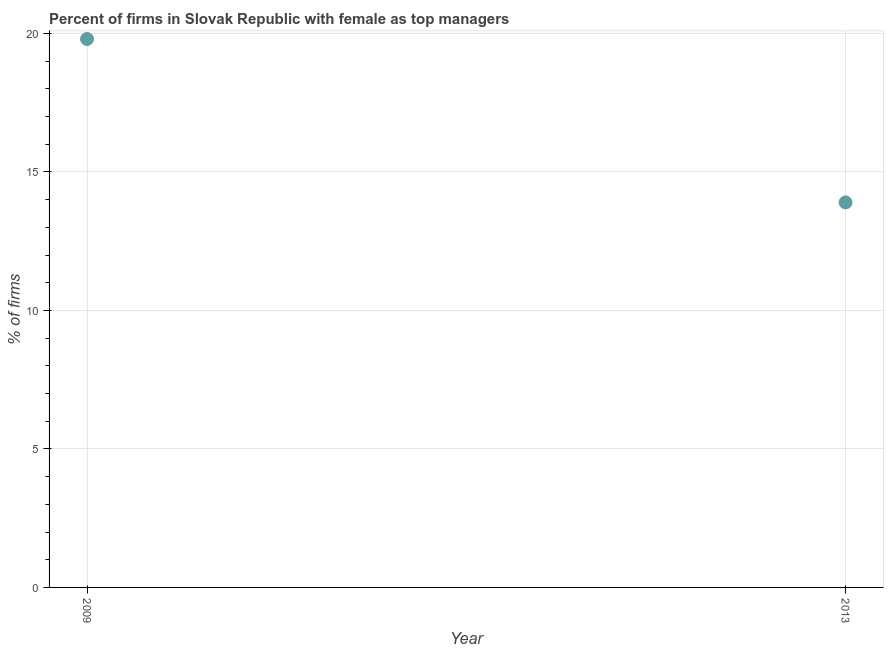Across all years, what is the maximum percentage of firms with female as top manager?
Provide a succinct answer. 19.8. In which year was the percentage of firms with female as top manager maximum?
Your response must be concise. 2009. In which year was the percentage of firms with female as top manager minimum?
Provide a succinct answer. 2013. What is the sum of the percentage of firms with female as top manager?
Provide a short and direct response. 33.7. What is the average percentage of firms with female as top manager per year?
Your response must be concise. 16.85. What is the median percentage of firms with female as top manager?
Provide a succinct answer. 16.85. In how many years, is the percentage of firms with female as top manager greater than 18 %?
Offer a terse response. 1. Do a majority of the years between 2009 and 2013 (inclusive) have percentage of firms with female as top manager greater than 10 %?
Provide a short and direct response. Yes. What is the ratio of the percentage of firms with female as top manager in 2009 to that in 2013?
Offer a very short reply. 1.42. Is the percentage of firms with female as top manager in 2009 less than that in 2013?
Ensure brevity in your answer.  No. How many years are there in the graph?
Offer a very short reply. 2. What is the difference between two consecutive major ticks on the Y-axis?
Make the answer very short. 5. Does the graph contain any zero values?
Offer a terse response. No. Does the graph contain grids?
Provide a succinct answer. Yes. What is the title of the graph?
Offer a terse response. Percent of firms in Slovak Republic with female as top managers. What is the label or title of the Y-axis?
Your answer should be very brief. % of firms. What is the % of firms in 2009?
Keep it short and to the point. 19.8. What is the ratio of the % of firms in 2009 to that in 2013?
Your answer should be compact. 1.42. 